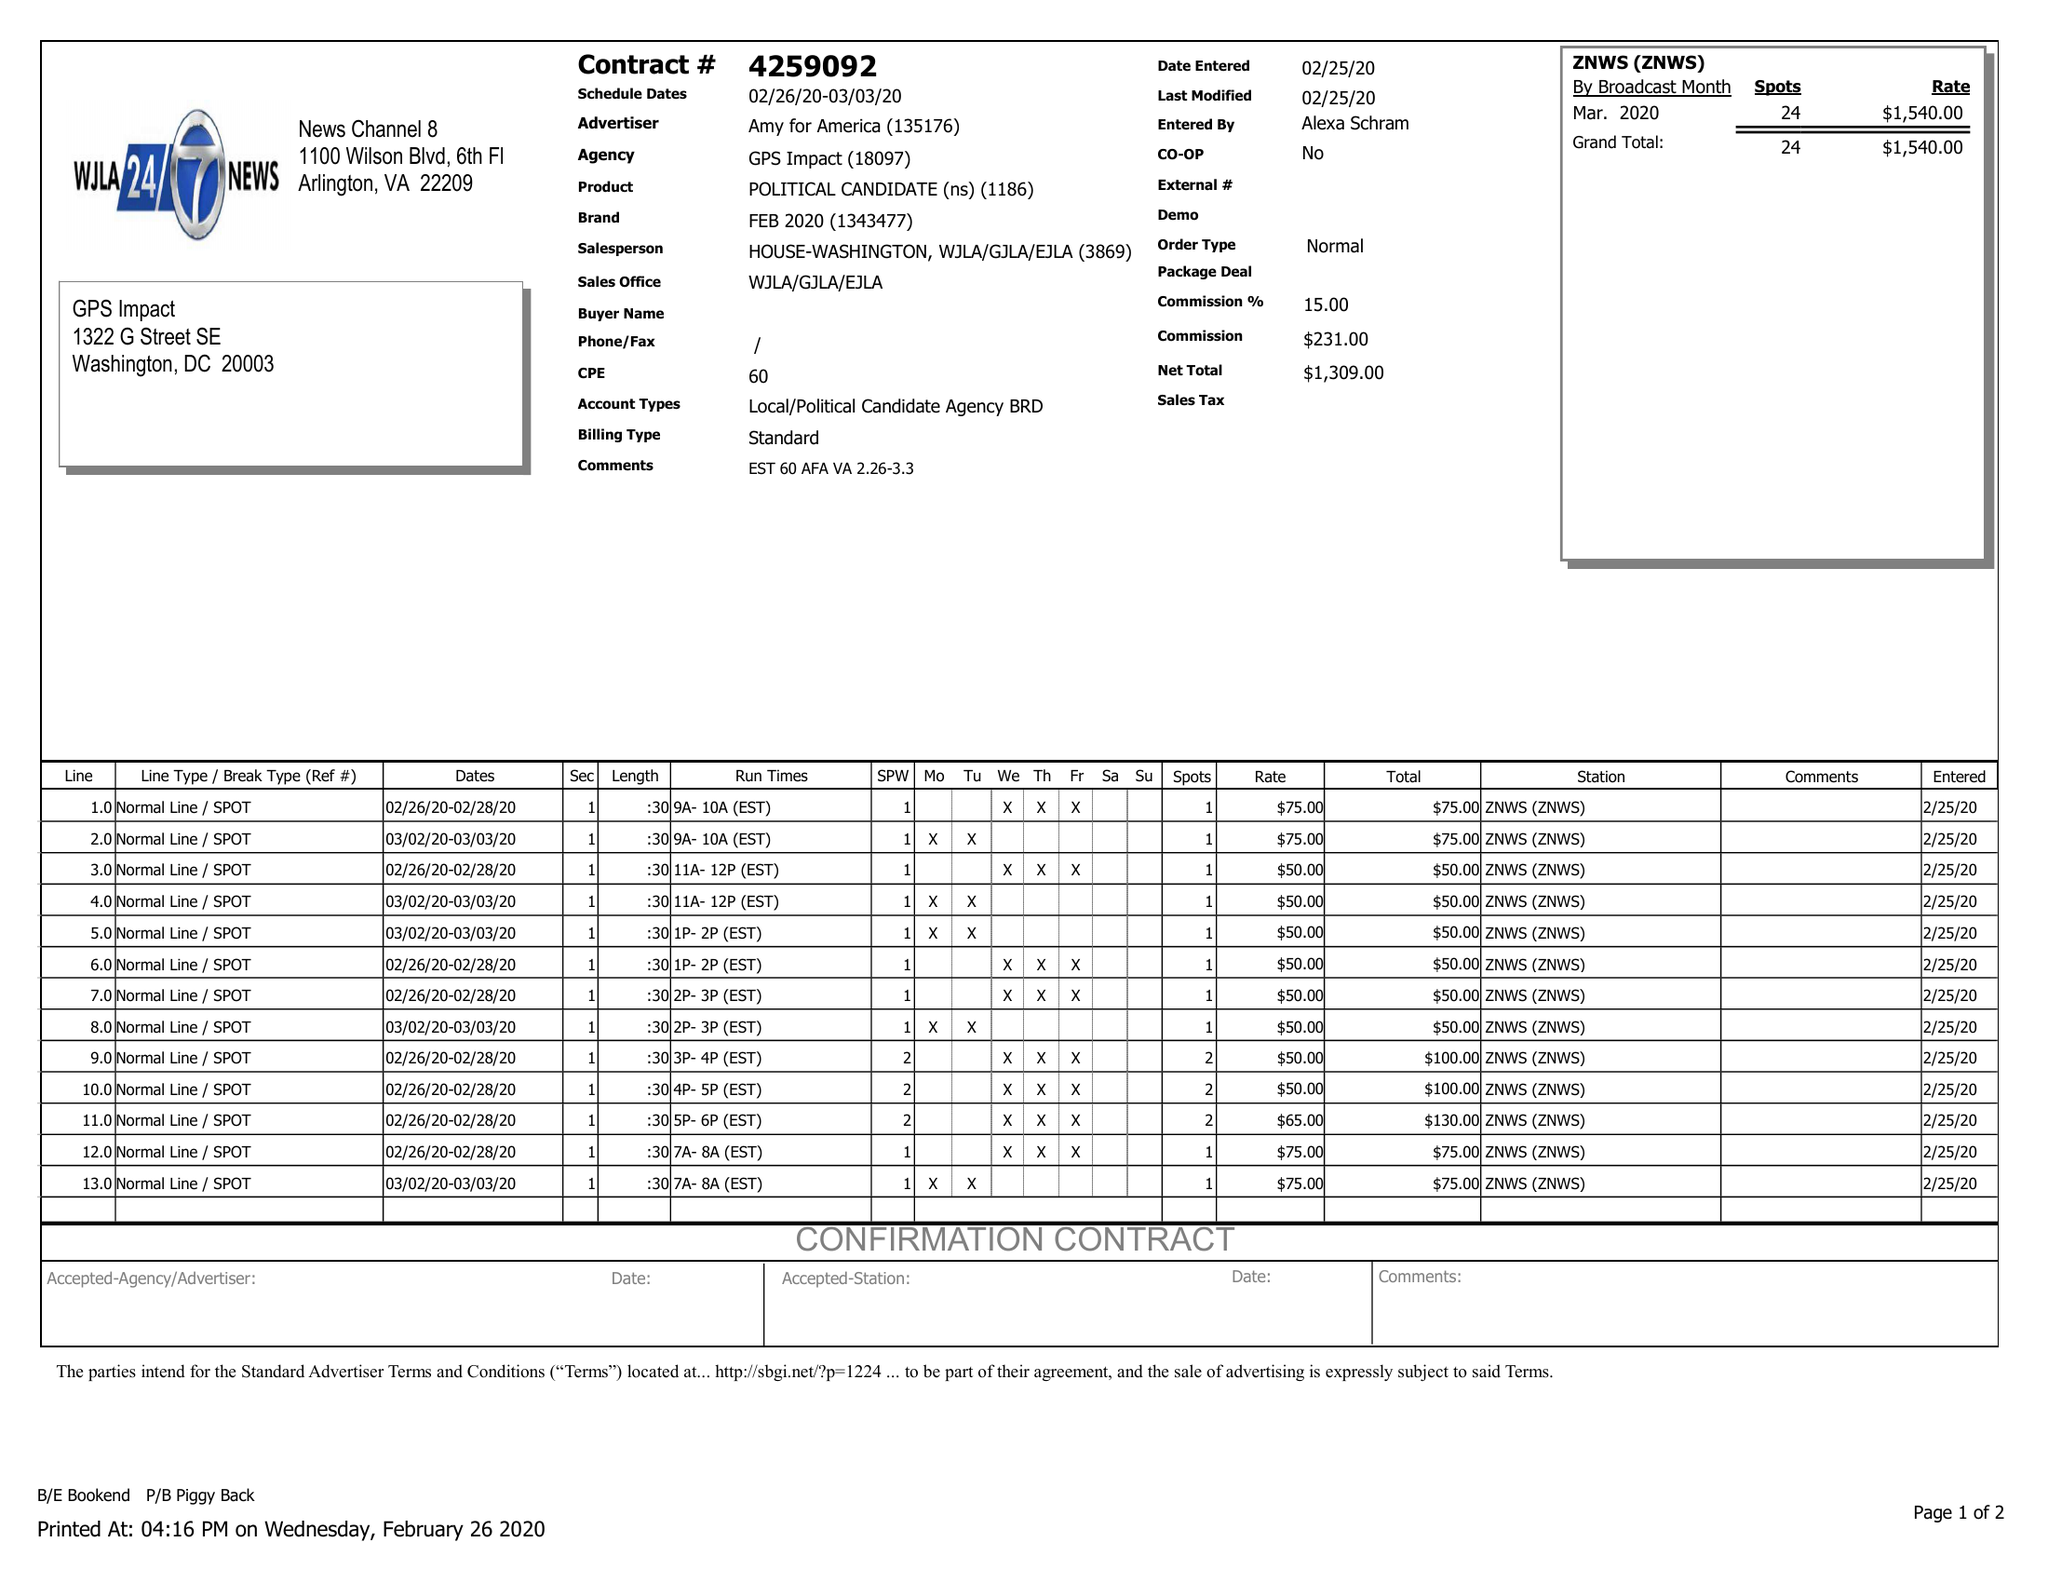What is the value for the gross_amount?
Answer the question using a single word or phrase. 1540.00 